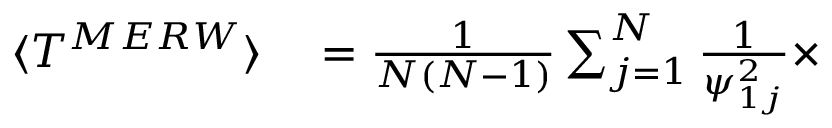<formula> <loc_0><loc_0><loc_500><loc_500>\begin{array} { r l } { \langle T ^ { M E R W } \rangle } & = \frac { 1 } { N ( N - 1 ) } \sum _ { j = 1 } ^ { N } \frac { 1 } { \psi _ { 1 j } ^ { 2 } } \times } \end{array}</formula> 